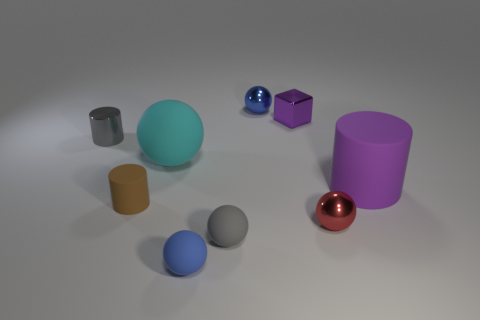How many rubber objects are on the left side of the big matte cylinder and on the right side of the big cyan thing?
Make the answer very short. 2. There is a shiny ball in front of the gray thing that is left of the large cyan sphere; what is its color?
Your response must be concise. Red. How many blocks have the same color as the small matte cylinder?
Offer a terse response. 0. Does the tiny metal cylinder have the same color as the large matte object that is to the left of the tiny block?
Provide a succinct answer. No. Are there fewer small gray cylinders than shiny things?
Give a very brief answer. Yes. Is the number of small purple shiny cubes that are behind the tiny blue metallic object greater than the number of purple matte things that are to the left of the cube?
Give a very brief answer. No. Are the brown cylinder and the tiny gray cylinder made of the same material?
Provide a succinct answer. No. There is a gray thing left of the large cyan object; how many small objects are in front of it?
Offer a terse response. 4. There is a cylinder to the left of the brown cylinder; is its color the same as the large sphere?
Your response must be concise. No. How many objects are either purple cylinders or small gray objects in front of the large matte sphere?
Your answer should be very brief. 2. 